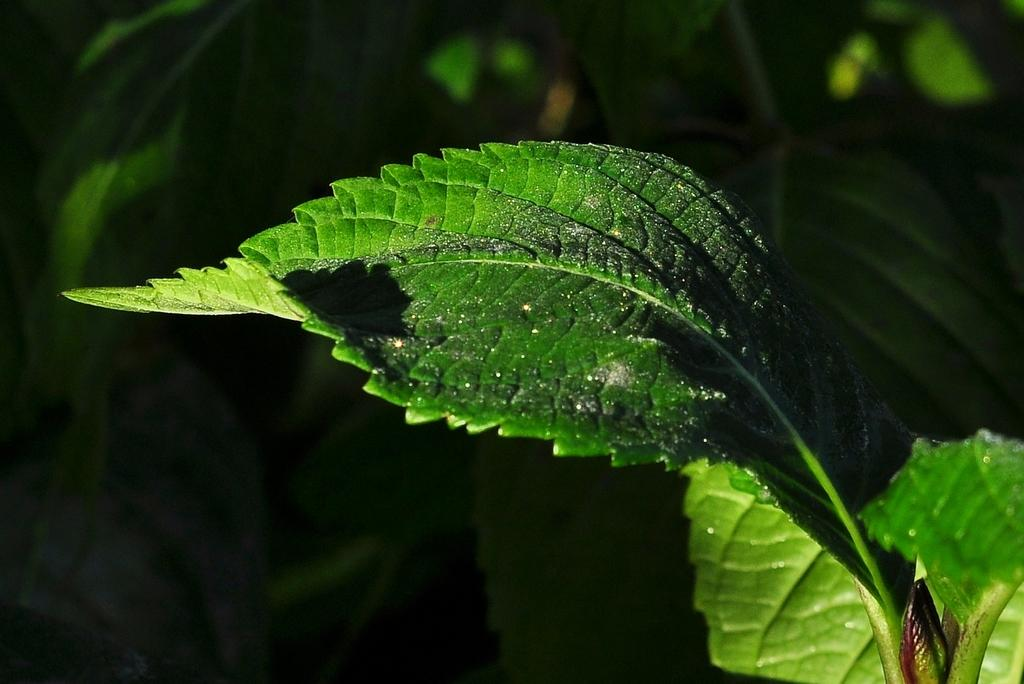What is the main subject of the image? There is a leaf in the image. Can you describe the background of the image? There are leaves in the background of the image. How does the leaf cover the stem in the image? There is no stem present in the image, as it only features a single leaf. 